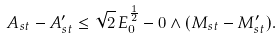Convert formula to latex. <formula><loc_0><loc_0><loc_500><loc_500>A _ { s t } - A _ { s t } ^ { \prime } \leq \sqrt { 2 } \, E _ { 0 } ^ { \frac { 1 } { 2 } } - 0 \wedge ( M _ { s t } - M _ { s t } ^ { \prime } ) .</formula> 